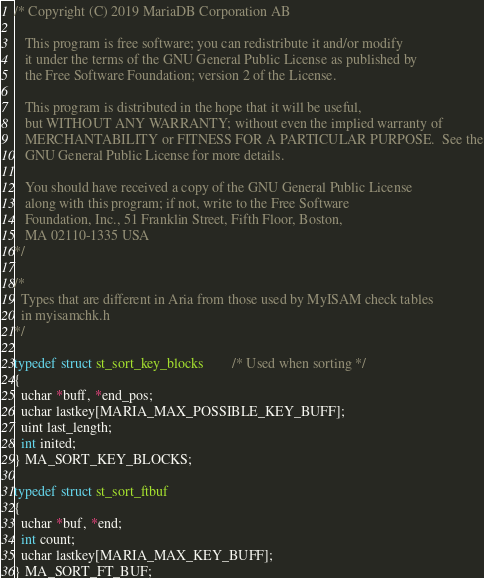<code> <loc_0><loc_0><loc_500><loc_500><_C_>/* Copyright (C) 2019 MariaDB Corporation AB

   This program is free software; you can redistribute it and/or modify
   it under the terms of the GNU General Public License as published by
   the Free Software Foundation; version 2 of the License.

   This program is distributed in the hope that it will be useful,
   but WITHOUT ANY WARRANTY; without even the implied warranty of
   MERCHANTABILITY or FITNESS FOR A PARTICULAR PURPOSE.  See the
   GNU General Public License for more details.

   You should have received a copy of the GNU General Public License
   along with this program; if not, write to the Free Software
   Foundation, Inc., 51 Franklin Street, Fifth Floor, Boston,
   MA 02110-1335 USA
*/

/*
  Types that are different in Aria from those used by MyISAM check tables
  in myisamchk.h
*/

typedef struct st_sort_key_blocks		/* Used when sorting */
{
  uchar *buff, *end_pos;
  uchar lastkey[MARIA_MAX_POSSIBLE_KEY_BUFF];
  uint last_length;
  int inited;
} MA_SORT_KEY_BLOCKS;

typedef struct st_sort_ftbuf
{
  uchar *buf, *end;
  int count;
  uchar lastkey[MARIA_MAX_KEY_BUFF];
} MA_SORT_FT_BUF;
</code> 